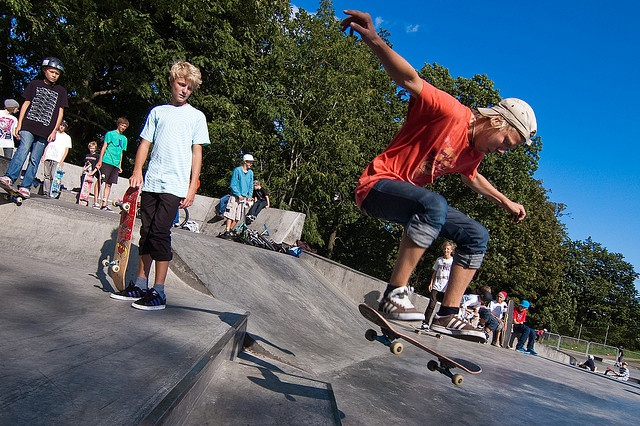Describe the objects in this image and their specific colors. I can see people in darkgreen, black, maroon, gray, and brown tones, people in darkgreen, white, black, tan, and brown tones, people in darkgreen, black, gray, and darkgray tones, people in darkgreen, black, darkgray, gray, and lightgray tones, and people in darkgreen, black, turquoise, and lightgray tones in this image. 